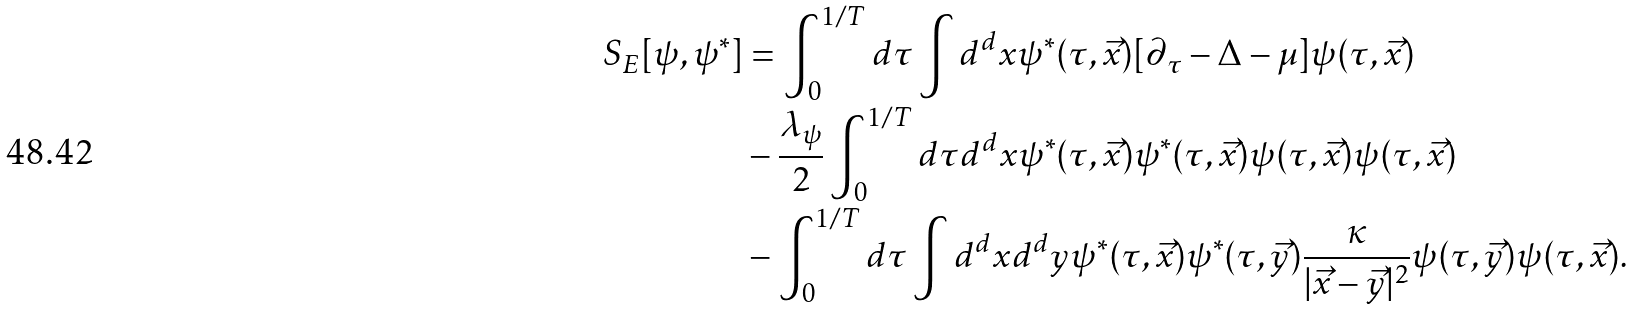<formula> <loc_0><loc_0><loc_500><loc_500>S _ { E } [ \psi , \psi ^ { * } ] & = \int _ { 0 } ^ { 1 / T } d \tau \int d ^ { d } x \psi ^ { * } ( \tau , \vec { x } ) [ \partial _ { \tau } - \Delta - \mu ] \psi ( \tau , \vec { x } ) \\ & - \frac { \lambda _ { \psi } } { 2 } \int _ { 0 } ^ { 1 / T } d \tau d ^ { d } x \psi ^ { * } ( \tau , \vec { x } ) \psi ^ { * } ( \tau , \vec { x } ) \psi ( \tau , \vec { x } ) \psi ( \tau , \vec { x } ) \\ & - \int _ { 0 } ^ { 1 / T } d \tau \int d ^ { d } x d ^ { d } y \psi ^ { * } ( \tau , \vec { x } ) \psi ^ { * } ( \tau , \vec { y } ) \frac { \kappa } { | \vec { x } - \vec { y } | ^ { 2 } } \psi ( \tau , \vec { y } ) \psi ( \tau , \vec { x } ) .</formula> 